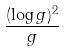Convert formula to latex. <formula><loc_0><loc_0><loc_500><loc_500>\frac { ( \log g ) ^ { 2 } } { g }</formula> 